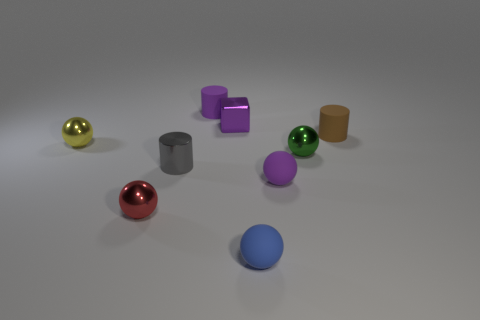There is a metal cylinder; is it the same color as the matte cylinder left of the tiny brown thing?
Provide a succinct answer. No. There is a gray object; how many tiny metal cubes are in front of it?
Make the answer very short. 0. Are there fewer small shiny spheres that are to the right of the red ball than rubber things?
Offer a terse response. Yes. What is the color of the small metal block?
Ensure brevity in your answer.  Purple. Do the sphere that is behind the green metal ball and the shiny cube have the same color?
Offer a very short reply. No. There is another rubber object that is the same shape as the blue object; what color is it?
Make the answer very short. Purple. How many big things are metal things or purple matte objects?
Give a very brief answer. 0. There is a cylinder that is on the right side of the blue matte ball; what is its size?
Your response must be concise. Small. Is there another small matte cube that has the same color as the tiny block?
Provide a short and direct response. No. Is the shiny block the same color as the tiny metal cylinder?
Give a very brief answer. No. 